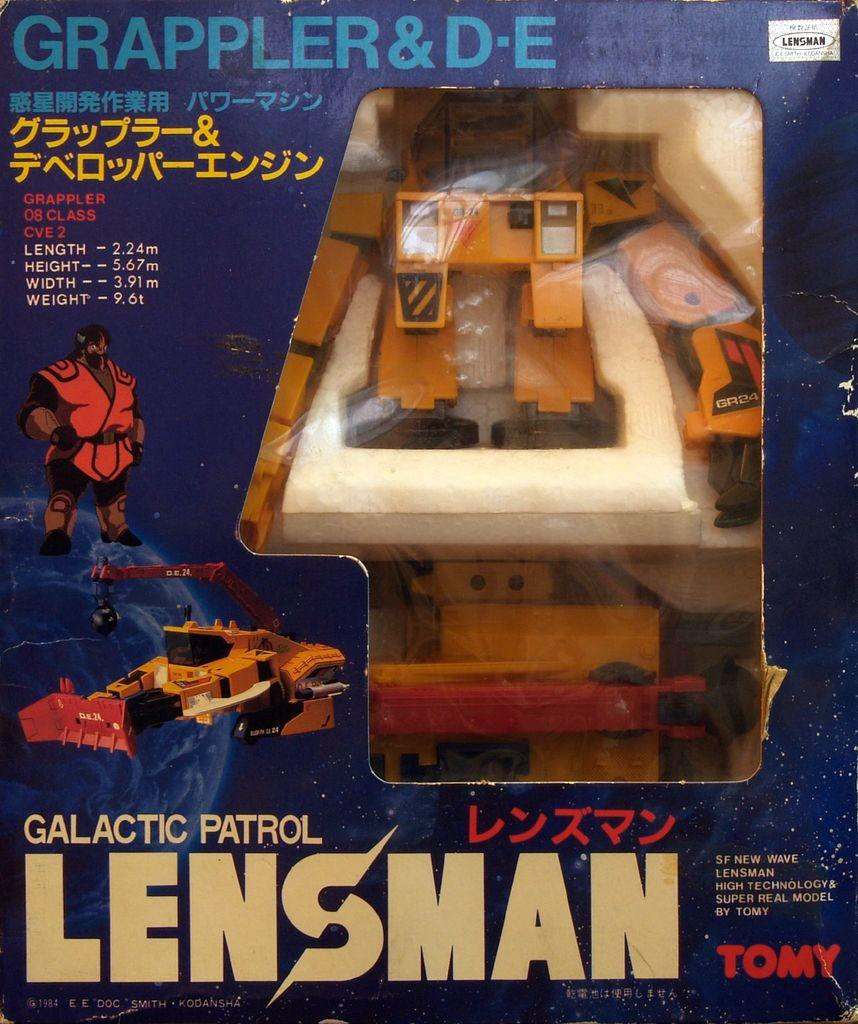Provide a one-sentence caption for the provided image. old toy from the brand galatic patrol lensman. 